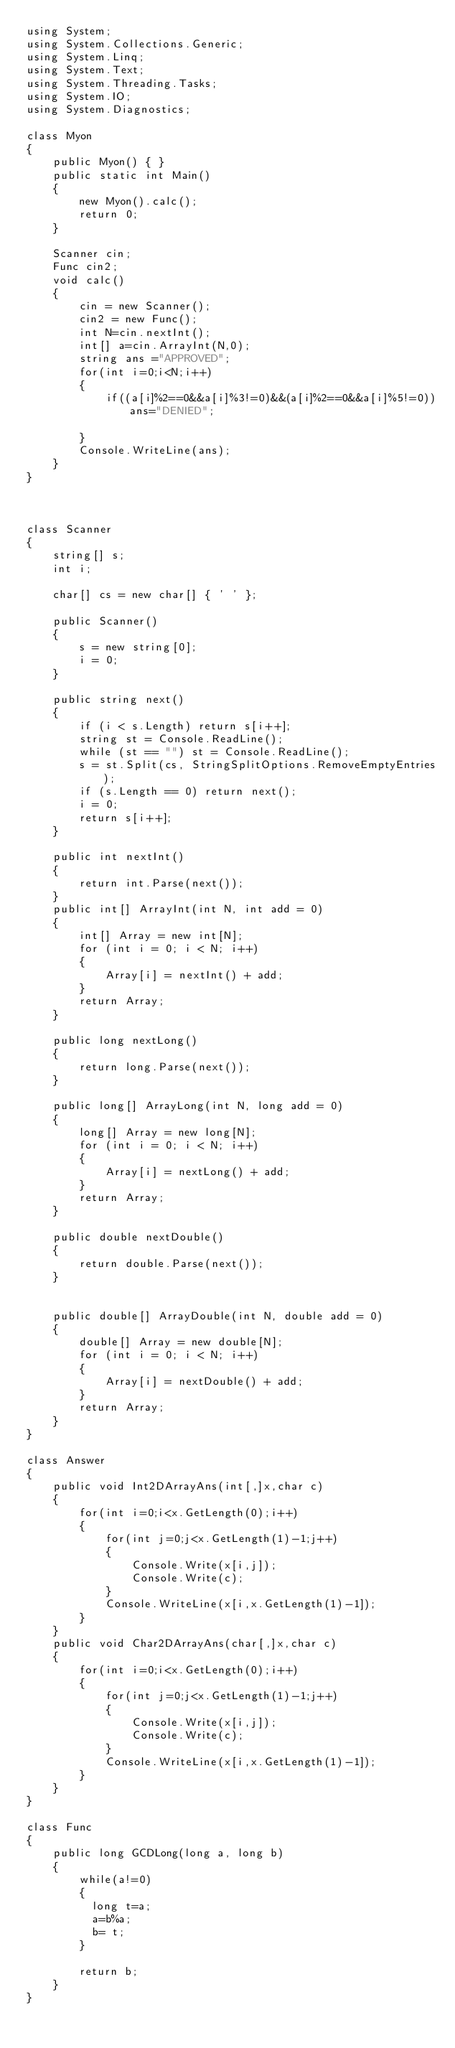Convert code to text. <code><loc_0><loc_0><loc_500><loc_500><_C#_>using System;
using System.Collections.Generic;
using System.Linq;
using System.Text;
using System.Threading.Tasks;
using System.IO;
using System.Diagnostics;

class Myon
{
    public Myon() { }
    public static int Main()
    {
        new Myon().calc();
        return 0;
    }

    Scanner cin;
    Func cin2;
    void calc()
    {
        cin = new Scanner();
        cin2 = new Func();
        int N=cin.nextInt();
        int[] a=cin.ArrayInt(N,0);
        string ans ="APPROVED";
        for(int i=0;i<N;i++)
        {
            if((a[i]%2==0&&a[i]%3!=0)&&(a[i]%2==0&&a[i]%5!=0))ans="DENIED";
            
        }
        Console.WriteLine(ans);
    }
}



class Scanner
{
    string[] s;
    int i;

    char[] cs = new char[] { ' ' };

    public Scanner()
    {
        s = new string[0];
        i = 0;
    }

    public string next()
    {
        if (i < s.Length) return s[i++];
        string st = Console.ReadLine();
        while (st == "") st = Console.ReadLine();
        s = st.Split(cs, StringSplitOptions.RemoveEmptyEntries);
        if (s.Length == 0) return next();
        i = 0;
        return s[i++];
    }

    public int nextInt()
    {
        return int.Parse(next());
    }
    public int[] ArrayInt(int N, int add = 0)
    {
        int[] Array = new int[N];
        for (int i = 0; i < N; i++)
        {
            Array[i] = nextInt() + add;
        }
        return Array;
    }

    public long nextLong()
    {
        return long.Parse(next());
    }

    public long[] ArrayLong(int N, long add = 0)
    {
        long[] Array = new long[N];
        for (int i = 0; i < N; i++)
        {
            Array[i] = nextLong() + add;
        }
        return Array;
    }

    public double nextDouble()
    {
        return double.Parse(next());
    }


    public double[] ArrayDouble(int N, double add = 0)
    {
        double[] Array = new double[N];
        for (int i = 0; i < N; i++)
        {
            Array[i] = nextDouble() + add;
        }
        return Array;
    }
}

class Answer
{
    public void Int2DArrayAns(int[,]x,char c)
    {
        for(int i=0;i<x.GetLength(0);i++)
        {
            for(int j=0;j<x.GetLength(1)-1;j++)
            {
                Console.Write(x[i,j]);
                Console.Write(c);
            }
            Console.WriteLine(x[i,x.GetLength(1)-1]);
        }
    }
    public void Char2DArrayAns(char[,]x,char c)
    {
        for(int i=0;i<x.GetLength(0);i++)
        {
            for(int j=0;j<x.GetLength(1)-1;j++)
            {
                Console.Write(x[i,j]);
                Console.Write(c);
            }
            Console.WriteLine(x[i,x.GetLength(1)-1]);
        }
    }
}

class Func
{
    public long GCDLong(long a, long b)
    {
        while(a!=0)
        {
          long t=a;
          a=b%a;
          b= t;
        }
      
        return b;        
    }
}</code> 